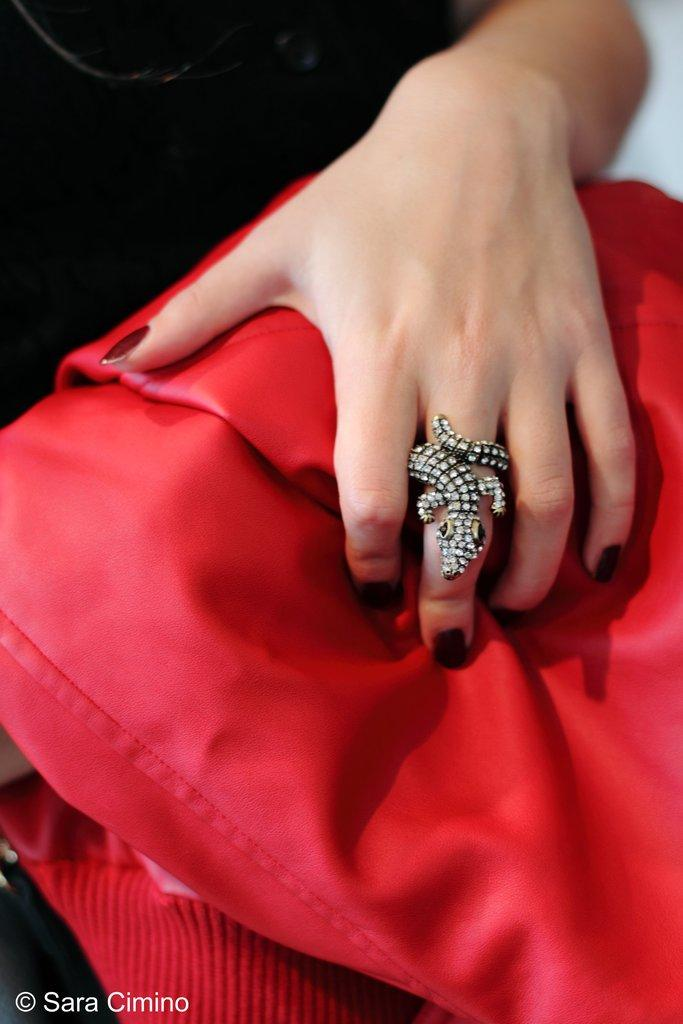What part of a person's body is visible in the image? There is a person's hand in the image. What accessory is the person's hand wearing? The person's hand has a ring on it. What color is the cloth that is visible in the image? There is a red color cloth in the image. What type of harmony can be heard in the image? There is no audible harmony present in the image, as it is a still image. What answer can be found in the image? There is no answer present in the image, as it is a visual representation without text or dialogue. 